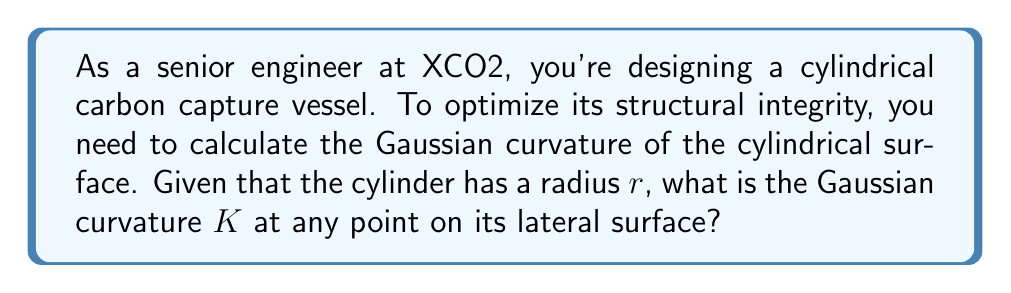What is the answer to this math problem? To compute the Gaussian curvature of a cylindrical surface, we'll follow these steps:

1) Recall that the Gaussian curvature $K$ is the product of the two principal curvatures, $K = k_1 \cdot k_2$.

2) For a cylinder of radius $r$, we can identify the principal curvatures:
   - In the direction parallel to the axis of the cylinder, the surface is a straight line. Thus, $k_1 = 0$.
   - In the direction perpendicular to the axis (around the circumference), the surface curves like a circle of radius $r$. Thus, $k_2 = \frac{1}{r}$.

3) Calculate the Gaussian curvature:

   $$K = k_1 \cdot k_2 = 0 \cdot \frac{1}{r} = 0$$

4) This result is independent of the position on the lateral surface of the cylinder, meaning the Gaussian curvature is constant everywhere on the surface (except at the ends).

5) Geometrically, this makes sense because a cylinder is a developable surface - it can be "unrolled" onto a plane without stretching or tearing, which is a characteristic of surfaces with zero Gaussian curvature.
Answer: $K = 0$ 